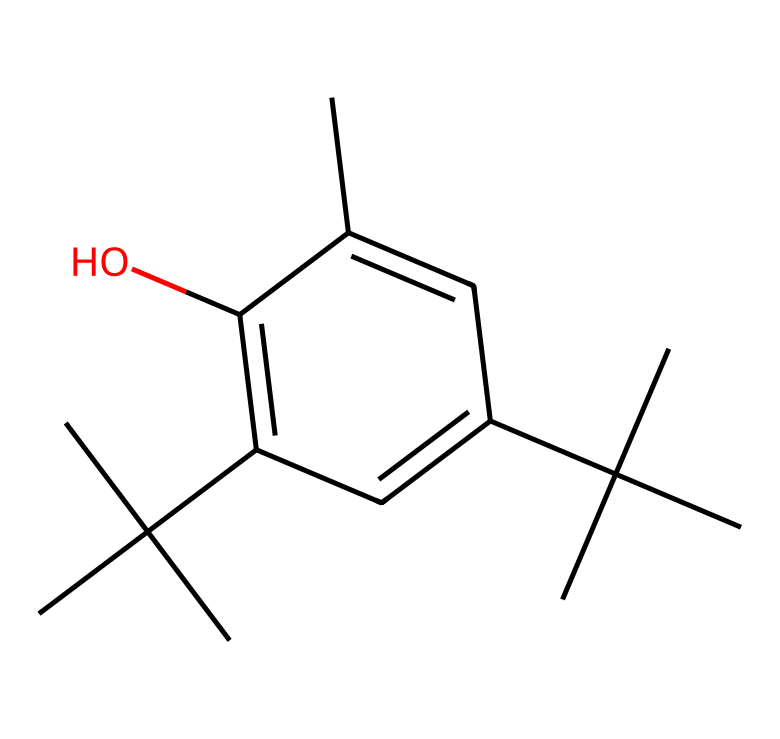What is the molecular formula of butylated hydroxytoluene (BHT)? To determine the molecular formula, count the number of each type of atom in the SMILES representation: there are 15 carbon (C) atoms, 24 hydrogen (H) atoms, and 1 oxygen (O) atom. This gives the molecular formula as C15H24O.
Answer: C15H24O How many rings are present in the structure? Inspecting the SMILES representation reveals that there is one benzene ring which is indicated by the notation with double bonds (C=C). Therefore, there is one ring present in the structure.
Answer: 1 What functional group is present in BHT? The presence of -OH in the structure indicates a hydroxyl functional group that defines the phenolic nature of BHT, which is consistent with its classification as a phenol.
Answer: hydroxyl Is BHT considered a phenol? According to its structure, BHT contains a hydroxyl (-OH) group attached to a benzene ring, matching the definition of a phenol. Thus, BHT is indeed classified as a phenol.
Answer: yes What is the significance of the bulky butyl groups in BHT? The bulky tert-butyl groups surrounding the hydroxyl-substituted aromatic ring provide steric hindrance, which enhances the stability and antioxidant properties of BHT, preventing its degradation and allowing it to effectively function as a preservative.
Answer: stabilize How many chiral centers does BHT have? Analyzing the structure, there are no carbon atoms that are attached to four different substituents, indicating that there are no chiral centers present in BHT.
Answer: 0 